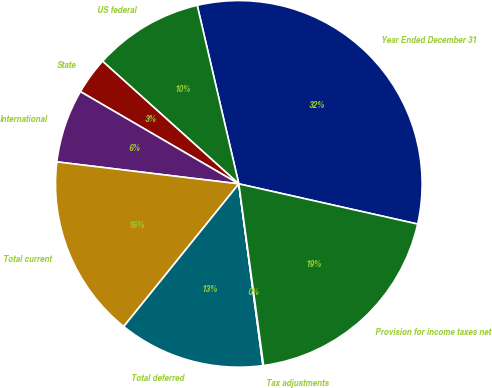Convert chart to OTSL. <chart><loc_0><loc_0><loc_500><loc_500><pie_chart><fcel>Year Ended December 31<fcel>US federal<fcel>State<fcel>International<fcel>Total current<fcel>Total deferred<fcel>Tax adjustments<fcel>Provision for income taxes net<nl><fcel>32.16%<fcel>9.69%<fcel>3.27%<fcel>6.48%<fcel>16.11%<fcel>12.9%<fcel>0.06%<fcel>19.32%<nl></chart> 